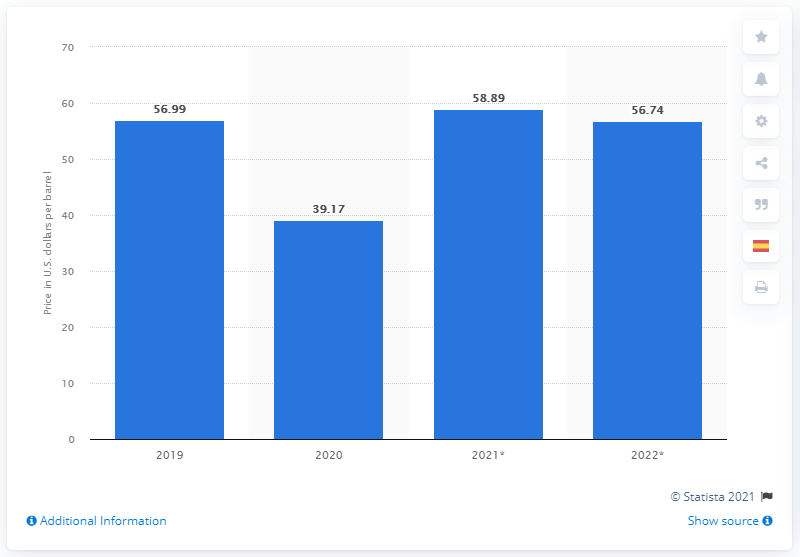Mention a couple of crucial points in this snapshot. As of the given date, the average price of West Texas Intermediate crude oil was 58.89 USD per barrel. 